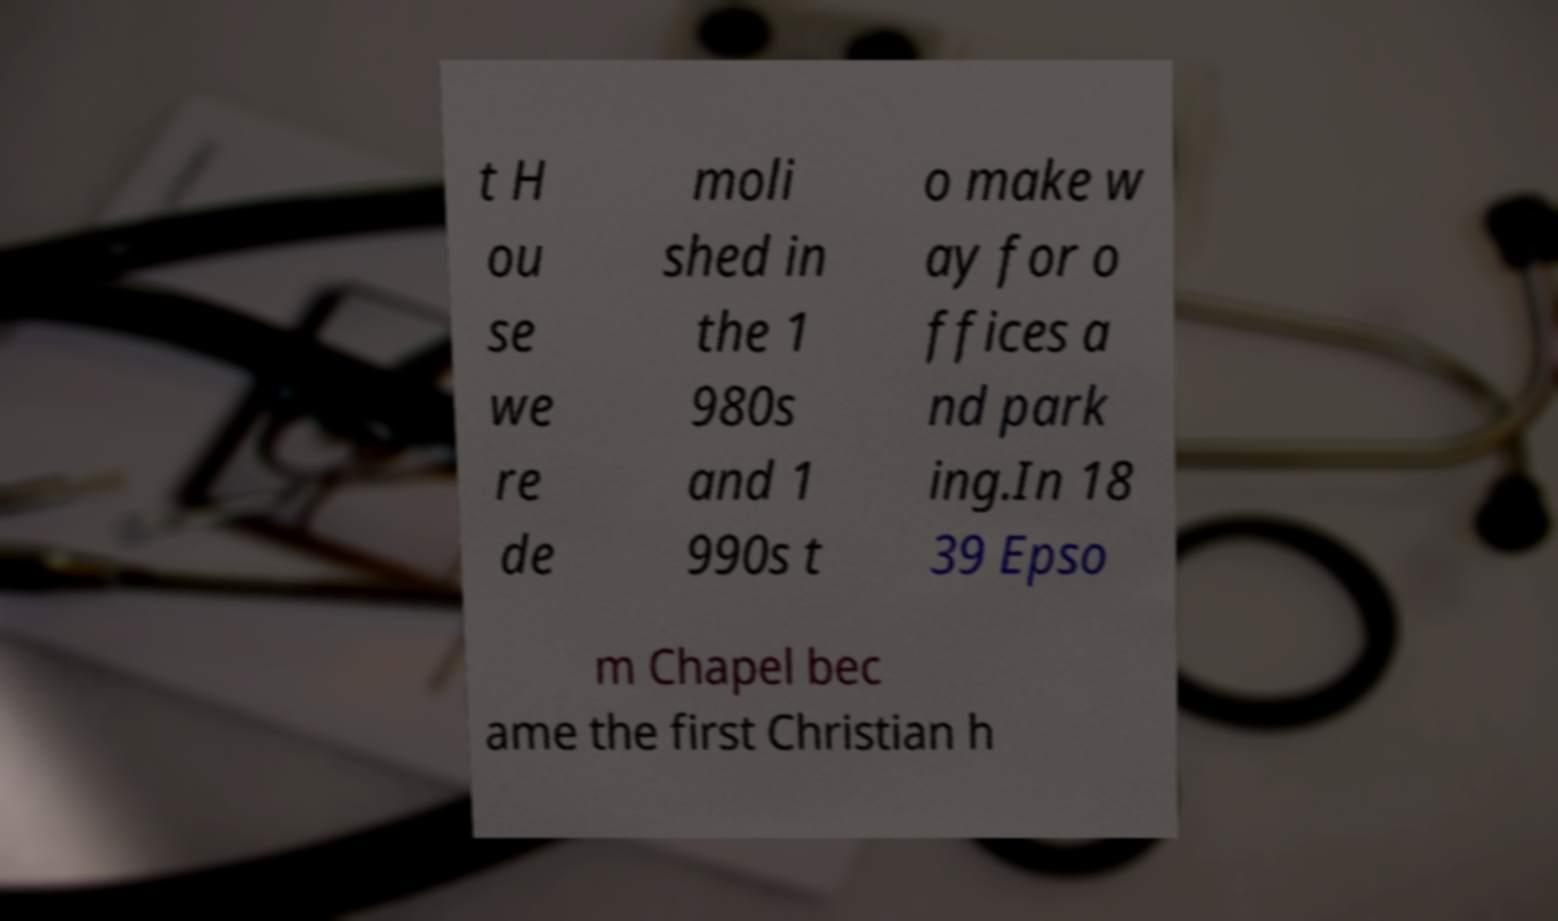For documentation purposes, I need the text within this image transcribed. Could you provide that? t H ou se we re de moli shed in the 1 980s and 1 990s t o make w ay for o ffices a nd park ing.In 18 39 Epso m Chapel bec ame the first Christian h 